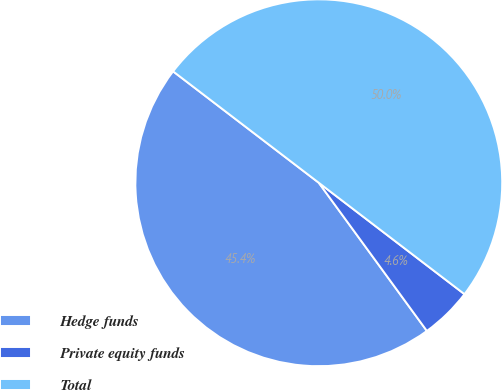<chart> <loc_0><loc_0><loc_500><loc_500><pie_chart><fcel>Hedge funds<fcel>Private equity funds<fcel>Total<nl><fcel>45.42%<fcel>4.58%<fcel>50.0%<nl></chart> 